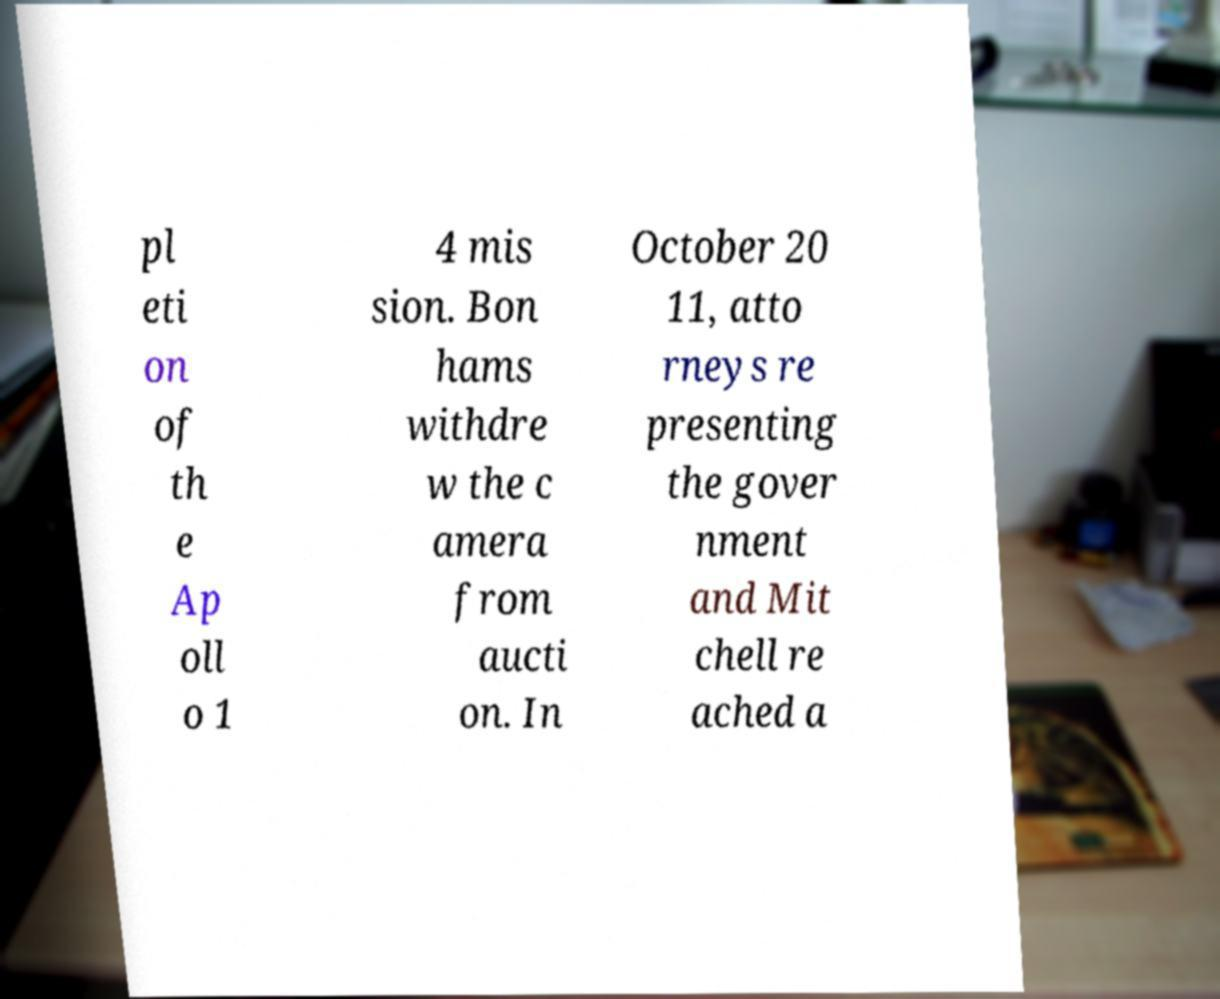Can you read and provide the text displayed in the image?This photo seems to have some interesting text. Can you extract and type it out for me? pl eti on of th e Ap oll o 1 4 mis sion. Bon hams withdre w the c amera from aucti on. In October 20 11, atto rneys re presenting the gover nment and Mit chell re ached a 